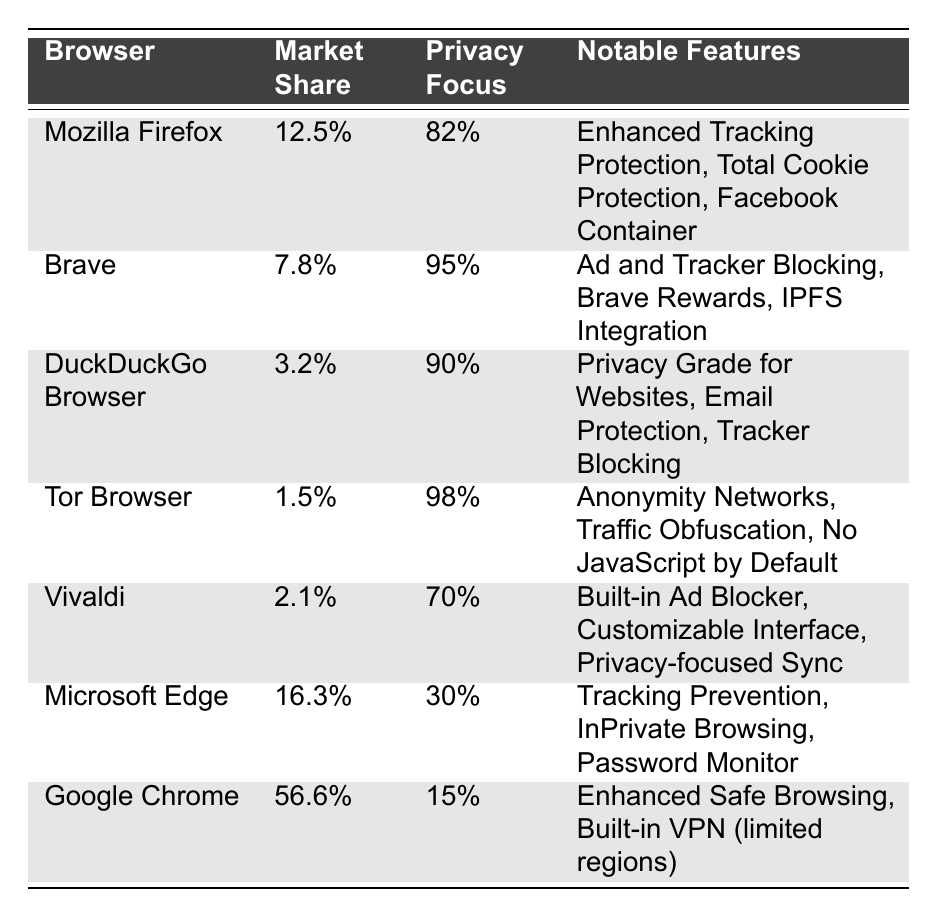What is the market share of Mozilla Firefox? The market share of Mozilla Firefox is directly indicated in the table under the "Market Share" column next to its name. It specifies 12.5%.
Answer: 12.5% Which browser has the highest market share? By examining the "Market Share" column, Google Chrome is listed with the highest market share of 56.6%.
Answer: Google Chrome What percentage of Brave users are privacy-focused? The table shows that 95% of Brave users fall under the "privacy focused" category as noted in the "Privacy Focus" column.
Answer: 95% Is the user segment for Tor Browser primarily privacy-focused? The table indicates that 98% of Tor Browser users are classified as privacy-focused, confirming that its user segment is primarily privacy-focused.
Answer: Yes What is the difference in market share between Microsoft Edge and DuckDuckGo Browser? The market share for Microsoft Edge is 16.3% and for DuckDuckGo Browser it is 3.2%. The difference is calculated as 16.3% - 3.2% = 13.1%.
Answer: 13.1% Which browser has the lowest market share? Upon inspecting the "Market Share" column, Tor Browser has the lowest market share, listed at 1.5%.
Answer: Tor Browser If you combine the market shares of Mozilla Firefox and Vivaldi, what is the total? The market shares are 12.5% for Mozilla Firefox and 2.1% for Vivaldi. Adding these two gives 12.5% + 2.1% = 14.6%.
Answer: 14.6% What percentage of users for Google Chrome is privacy-focused? The table states that only 15% of Google Chrome users are categorized as privacy-focused.
Answer: 15% How does the privacy focus percentage of DuckDuckGo Browser compare to that of Microsoft Edge? DuckDuckGo Browser has a 90% privacy focus while Microsoft Edge has 30%. This shows that DuckDuckGo is significantly more privacy-focused compared to Edge, with a difference of 90% - 30% = 60%.
Answer: 60% Which two browsers have a higher privacy focus percentage than 80%? Both Brave with 95% and Tor Browser with 98% have privacy focus percentages that exceed 80%.
Answer: Brave and Tor Browser What notable feature is common between Brave and DuckDuckGo Browser? The notable features for both browsers include mechanisms to block trackers: "Ad and Tracker Blocking" for Brave and "Tracker Blocking" for DuckDuckGo, making this a commonality.
Answer: Tracker Blocking 